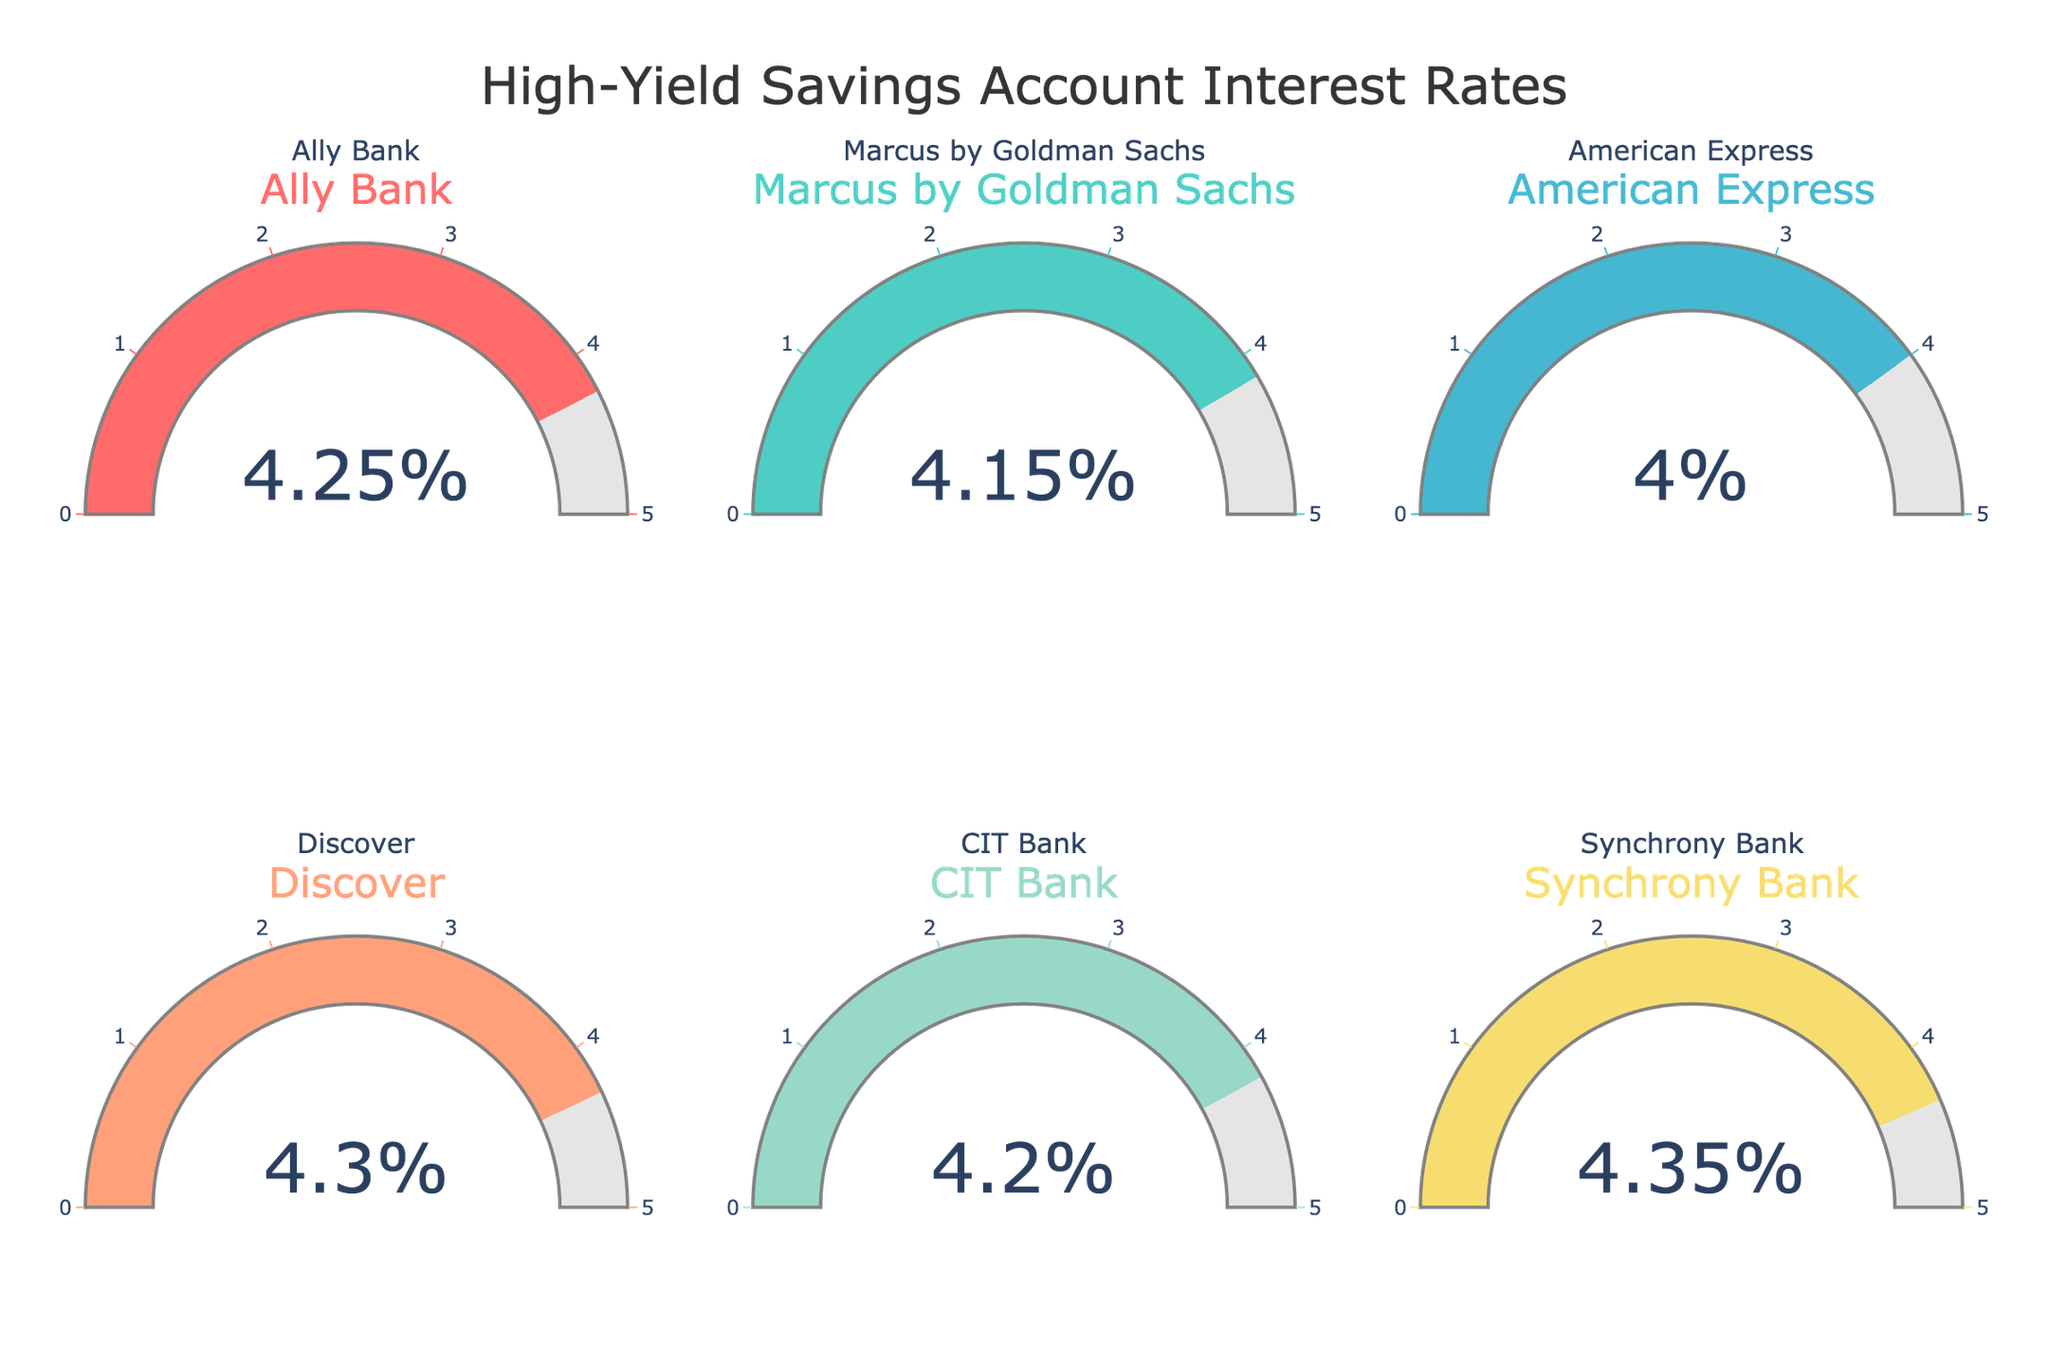What is the title of the figure? The title is located at the top center of the figure. It reads "High-Yield Savings Account Interest Rates".
Answer: High-Yield Savings Account Interest Rates How many banks' interest rates are shown in the figure? There are six gauges in the figure, each one representing a different bank's interest rate.
Answer: Six Which bank offers the highest interest rate? By looking at the values displayed on the gauges, Synchrony Bank offers the highest interest rate of 4.35%.
Answer: Synchrony Bank What is the difference in the interest rates between the bank with the highest rate and the bank with the lowest rate? The highest rate is 4.35% (Synchrony Bank) and the lowest rate is 4.00% (American Express). The difference is 4.35 - 4.00 = 0.35.
Answer: 0.35% What is the average interest rate across all the banks displayed? To find the average, sum all the interest rates (4.25 + 4.15 + 4.00 + 4.30 + 4.20 + 4.35) and then divide by the number of banks, which is 6. 4.25 + 4.15 + 4.00 + 4.30 + 4.20 + 4.35 = 25.25; 25.25 / 6 = 4.2083 (rounded to four decimal places).
Answer: 4.2083% How many banks offer an interest rate of at least 4.25%? Out of the six banks, four offer at least 4.25%: Ally Bank (4.25%), Discover (4.30%), CIT Bank (4.20%), and Synchrony Bank (4.35%).
Answer: Four Which bank's gauge has the smallest range from its interest rate to the maximum 5% mark? The range is calculated as 5 - interest rate. The smallest range is observed for Synchrony Bank with 5 - 4.35 = 0.65.
Answer: Synchrony Bank What is the total combined interest rate of Ally Bank and Marcus by Goldman Sachs? Add the interest rates of Ally Bank (4.25%) and Marcus by Goldman Sachs (4.15%). 4.25 + 4.15 = 8.40.
Answer: 8.40% Is the interest rate for Discover greater than that for CIT Bank? Discover's interest rate is 4.30%, which is higher than CIT Bank's rate of 4.20%.
Answer: Yes 